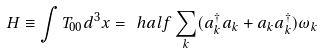Convert formula to latex. <formula><loc_0><loc_0><loc_500><loc_500>H \equiv \int T _ { 0 0 } d ^ { 3 } x = \ h a l f \sum _ { k } ( a _ { k } ^ { \dagger } a _ { k } + a _ { k } a _ { k } ^ { \dagger } ) \omega _ { k }</formula> 